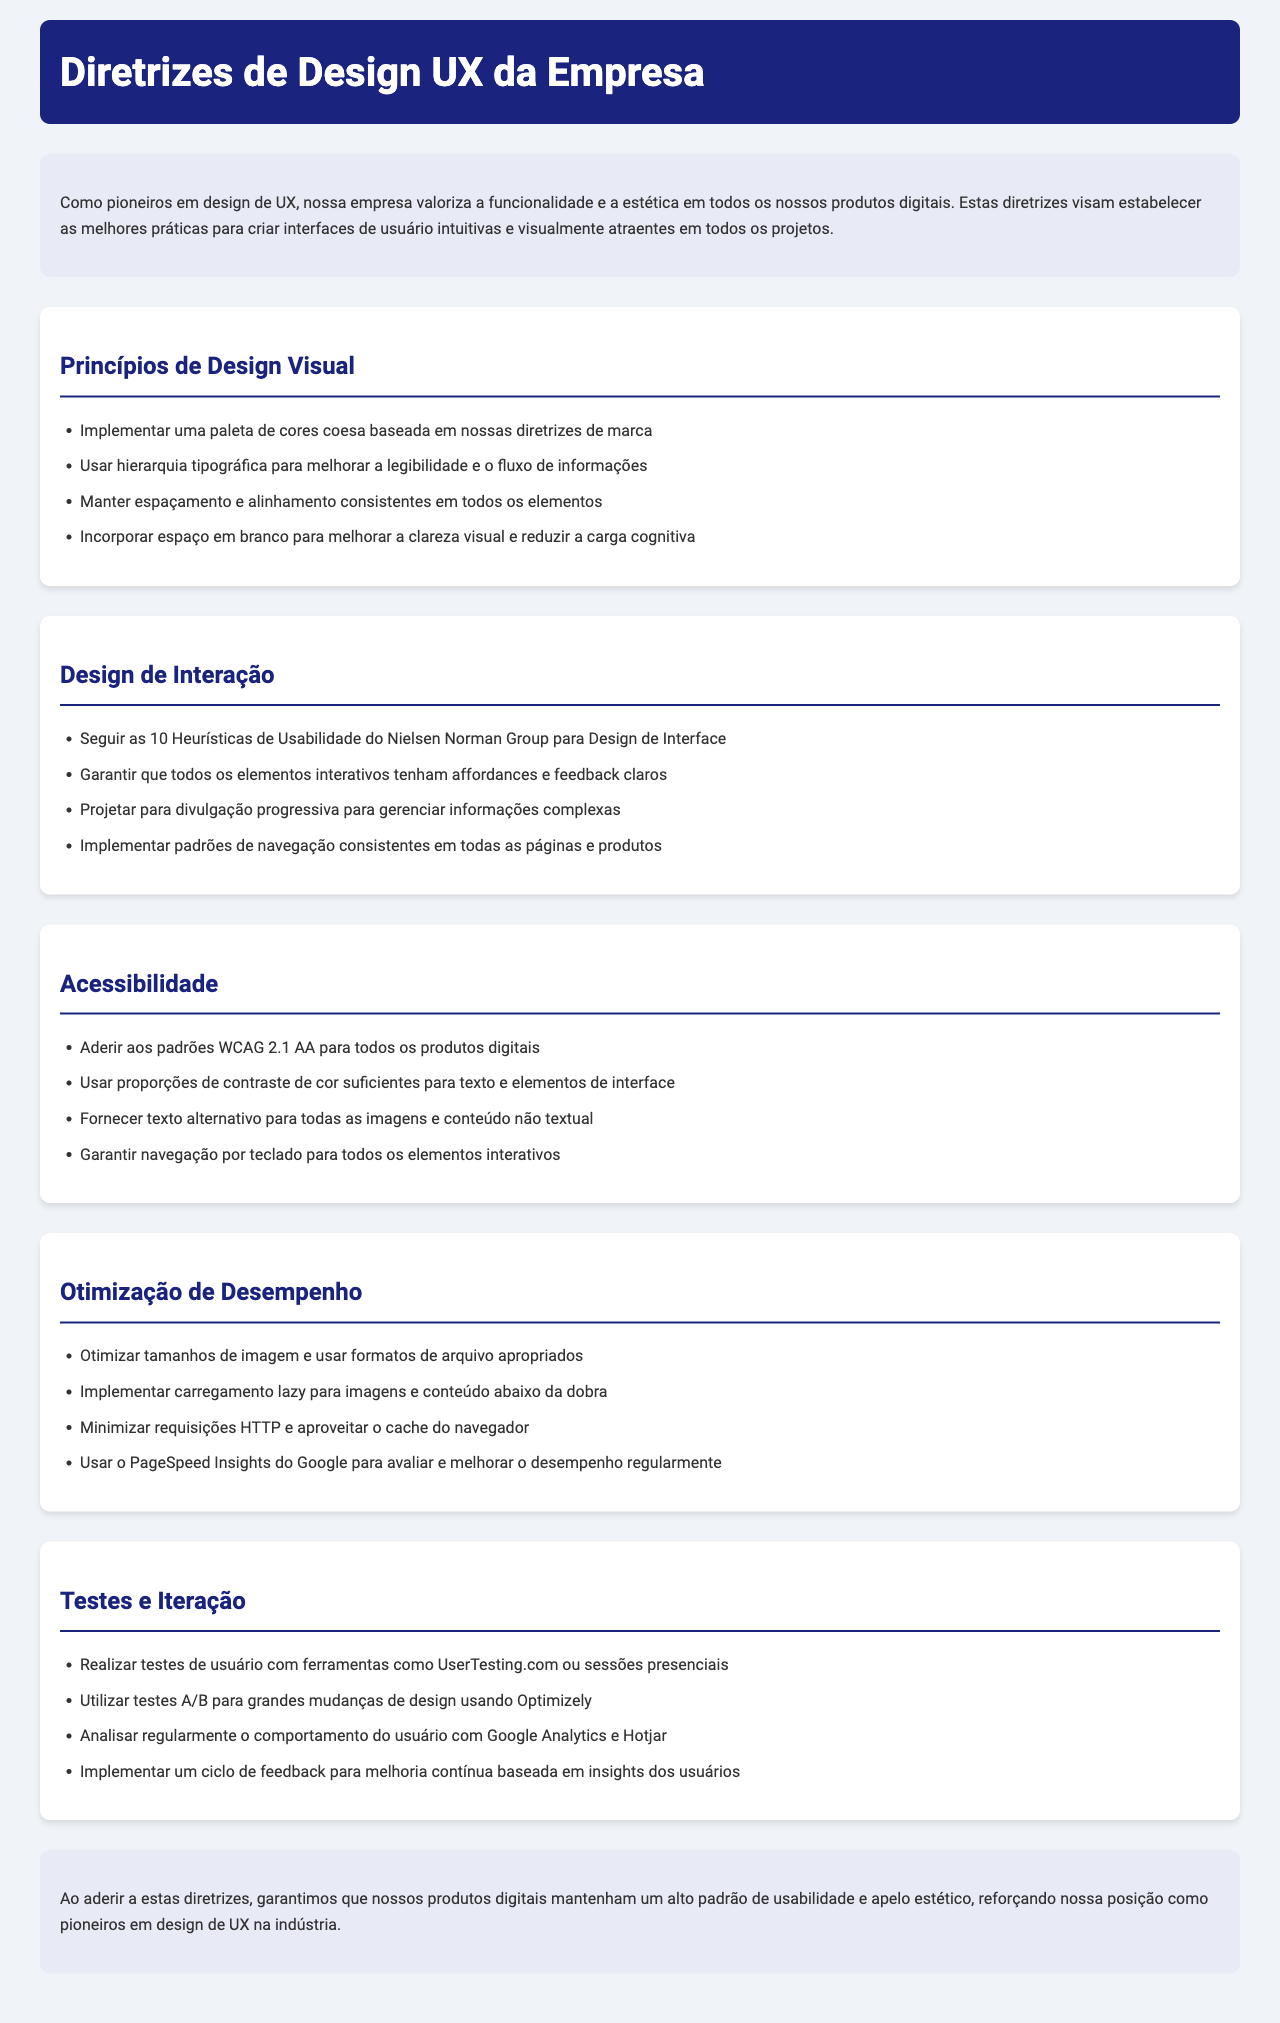Qual é o título do documento? O título do documento é exibido no cabeçalho.
Answer: Diretrizes de Design UX da Empresa Quantos princípios de design visual são mencionados? O número de princípios de design visual é indicado na lista.
Answer: quatro Qual é a cor de fundo da seção de introdução? A cor de fundo da seção de introdução é especificada na descrição.
Answer: #e8eaf6 O que se deve garantir para todos os elementos interativos? A exigência para elementos interativos é mencionada na seção de Design de Interação.
Answer: affordances e feedback claros Qual padrão de acessibilidade deve ser seguido? O padrão de acessibilidade é explicitado na seção de Acessibilidade.
Answer: WCAG 2.1 AA Quantas práticas são listadas na seção de Otimização de Desempenho? O total de práticas na seção de Otimização de Desempenho é indicado na lista.
Answer: quatro O que são utilizados para testar grandes mudanças de design? O que deve ser feito para testar grandes mudanças é mencionado na seção de Testes e Iteração.
Answer: testes A/B Qual é o objetivo principal ao seguir estas diretrizes? O objetivo é descrito na conclusão do documento.
Answer: manter um alto padrão de usabilidade e apelo estético 